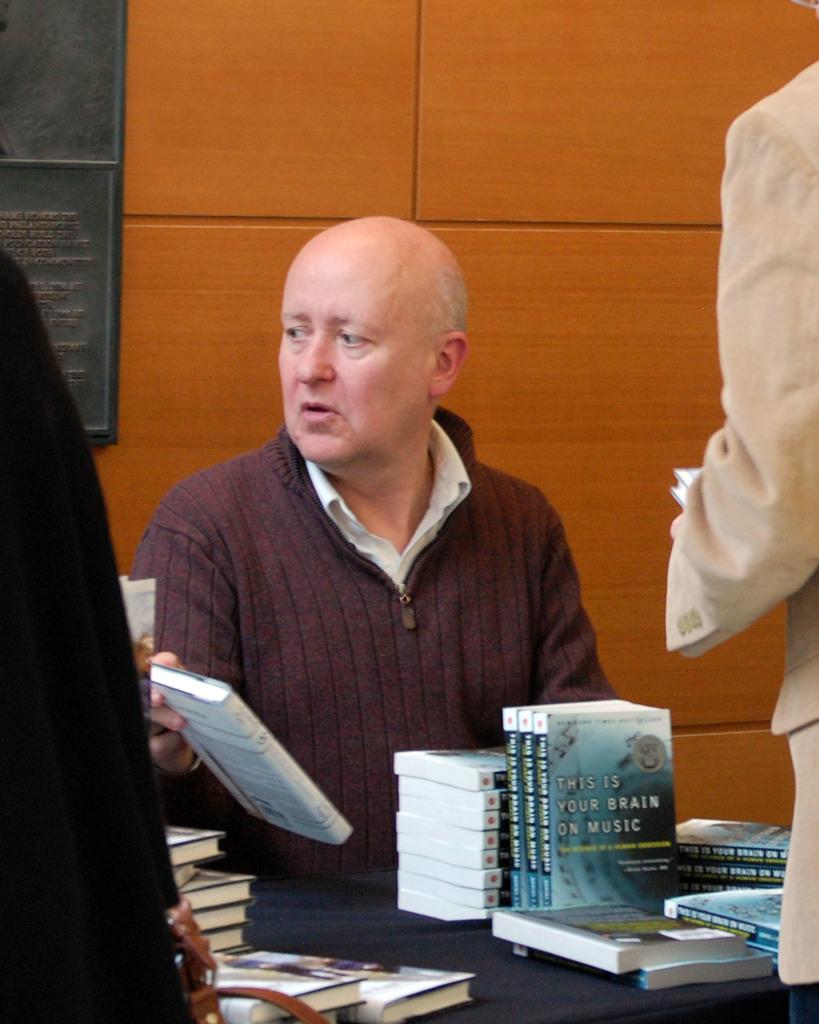What is the name of the book on the table?
Offer a very short reply. This is your brain on music. 